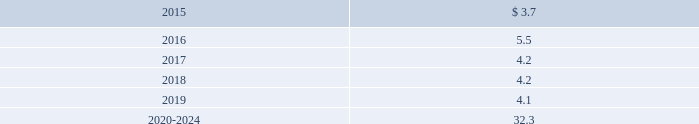Edwards lifesciences corporation notes to consolidated financial statements ( continued ) 12 .
Employee benefit plans ( continued ) equity and debt securities are valued at fair value based on quoted market prices reported on the active markets on which the individual securities are traded .
The insurance contracts are valued at the cash surrender value of the contracts , which is deemed to approximate its fair value .
The following benefit payments , which reflect expected future service , as appropriate , at december 31 , 2014 , are expected to be paid ( in millions ) : .
As of december 31 , 2014 , expected employer contributions for 2015 are $ 5.8 million .
Defined contribution plans the company 2019s employees in the united states and puerto rico are eligible to participate in a qualified 401 ( k ) and 1165 ( e ) plan , respectively .
In the united states , participants may contribute up to 25% ( 25 % ) of their eligible compensation ( subject to tax code limitation ) to the plan .
Edwards lifesciences matches the first 3% ( 3 % ) of the participant 2019s annual eligible compensation contributed to the plan on a dollar-for-dollar basis .
Edwards lifesciences matches the next 2% ( 2 % ) of the participant 2019s annual eligible compensation to the plan on a 50% ( 50 % ) basis .
In puerto rico , participants may contribute up to 25% ( 25 % ) of their annual compensation ( subject to tax code limitation ) to the plan .
Edwards lifesciences matches the first 4% ( 4 % ) of participant 2019s annual eligible compensation contributed to the plan on a 50% ( 50 % ) basis .
The company also provides a 2% ( 2 % ) profit sharing contribution calculated on eligible earnings for each employee .
Matching contributions relating to edwards lifesciences employees were $ 12.8 million , $ 12.0 million , and $ 10.8 million in 2014 , 2013 , and 2012 , respectively .
The company also has nonqualified deferred compensation plans for a select group of employees .
The plans provide eligible participants the opportunity to defer eligible compensation to future dates specified by the participant with a return based on investment alternatives selected by the participant .
The amount accrued under these nonqualified plans was $ 28.7 million and $ 25.9 million at december 31 , 2014 and 2013 , respectively .
13 .
Common stock treasury stock in may 2013 , the board of directors approved a stock repurchase program authorizing the company to purchase up to $ 750.0 million of the company 2019s common stock from time to time until december 31 , 2016 .
In july 2014 , the board of directors approved a new stock repurchase program providing for an additional $ 750.0 million of repurchases without a specified end date .
Stock repurchased under these programs will be used to offset obligations under the company 2019s employee stock option programs and reduce the total shares outstanding .
During 2014 , 2013 , and 2012 , the company repurchased 4.4 million , 6.8 million , and 4.0 million shares , respectively , at an aggregate cost of $ 300.9 million , $ 497.0 million , and $ 353.2 million , respectively , including shares purchased under the accelerated share repurchase ( 2018 2018asr 2019 2019 ) agreements described below and shares .
What was the average purchase price of company repurchased shares in 2014? 
Computations: (300.9 / 4.4)
Answer: 68.38636. 